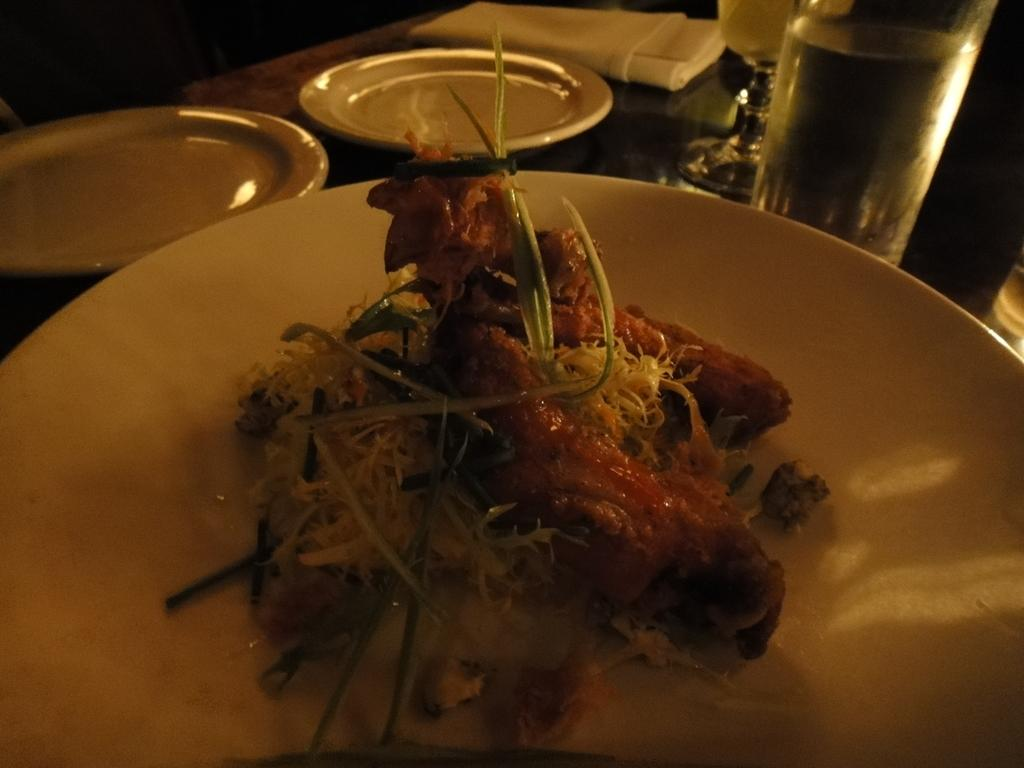What objects are present on the table in the image? There are plates, glasses, and napkins on the table in the image. What is on the plate with food? The plate with food has a meal on it. What is in the glass that is filled? The glass is filled with a drink. How many girls are playing on the street in the image? There are no girls or streets present in the image; it features a table with plates, glasses, and napkins. 